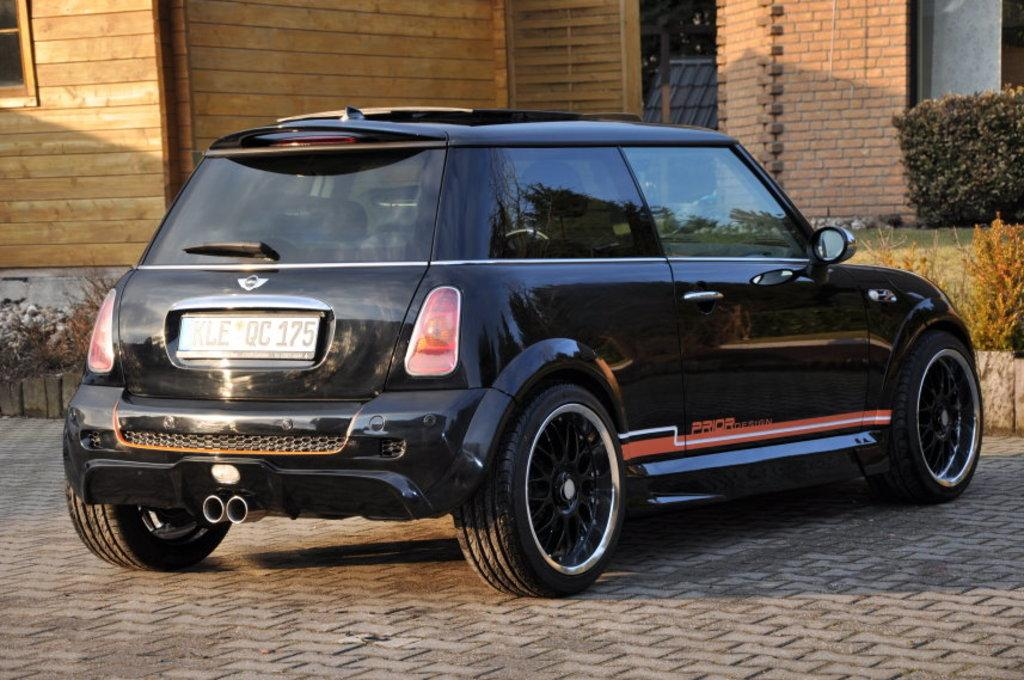What is the main subject of the image? There is a car in the image. What is the car doing in the image? The car is parked. What is the color of the car? The car appears to be black in color. What else can be seen in the image besides the car? There is a building, bushes, and plants visible in the image. Can you describe the building in the image? The building has a window and a glass door. What type of behavior can be observed in the celery in the image? There is no celery present in the image, so it is not possible to observe any behavior. 